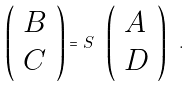Convert formula to latex. <formula><loc_0><loc_0><loc_500><loc_500>\left ( \begin{array} { l } B \\ C \end{array} \right ) = S \ \left ( \begin{array} { l } A \\ D \end{array} \right ) \ .</formula> 